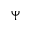<formula> <loc_0><loc_0><loc_500><loc_500>\Psi</formula> 